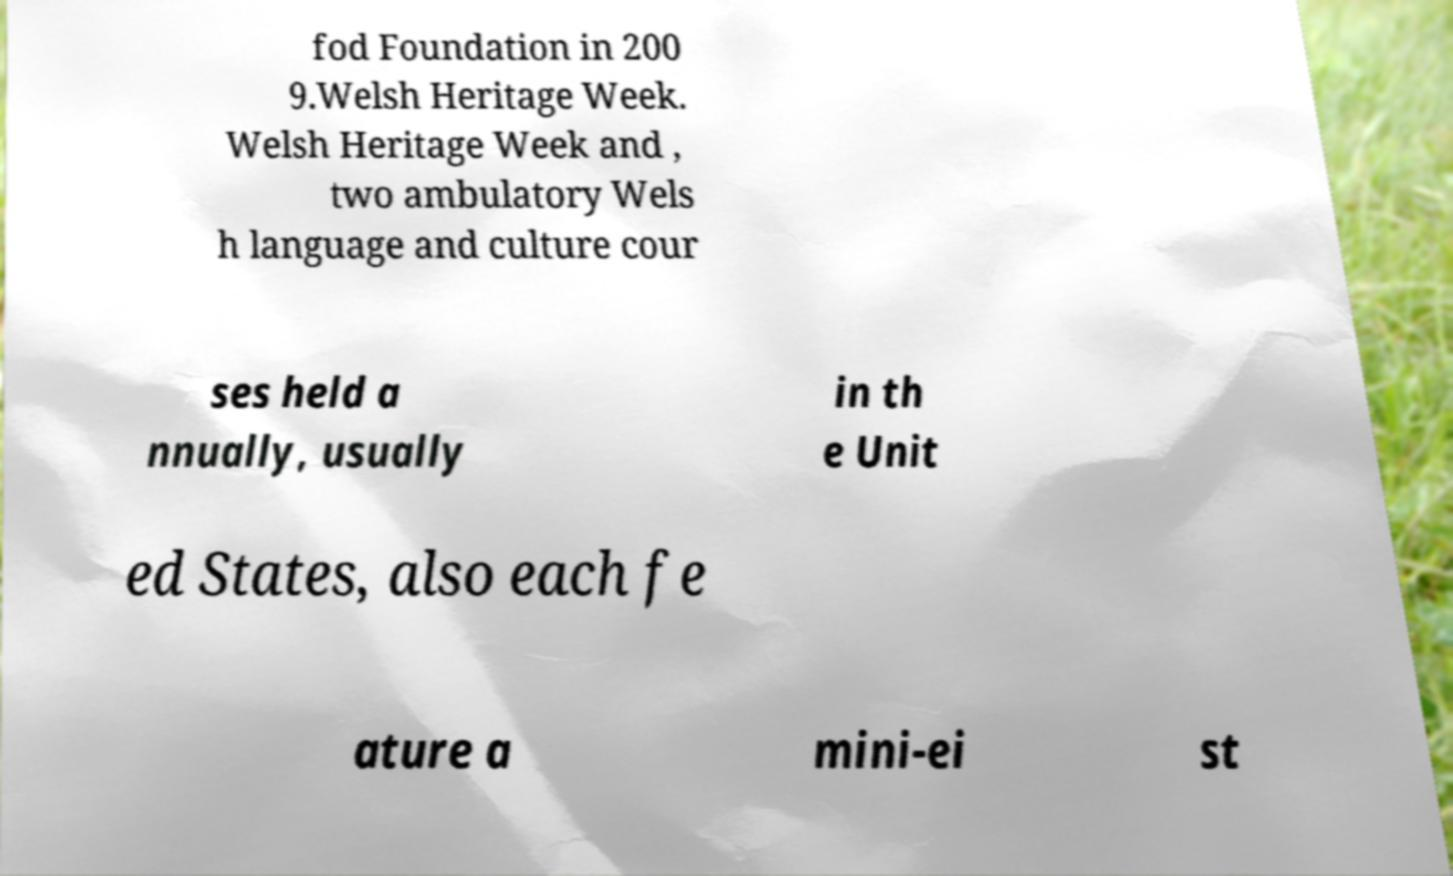Please identify and transcribe the text found in this image. fod Foundation in 200 9.Welsh Heritage Week. Welsh Heritage Week and , two ambulatory Wels h language and culture cour ses held a nnually, usually in th e Unit ed States, also each fe ature a mini-ei st 